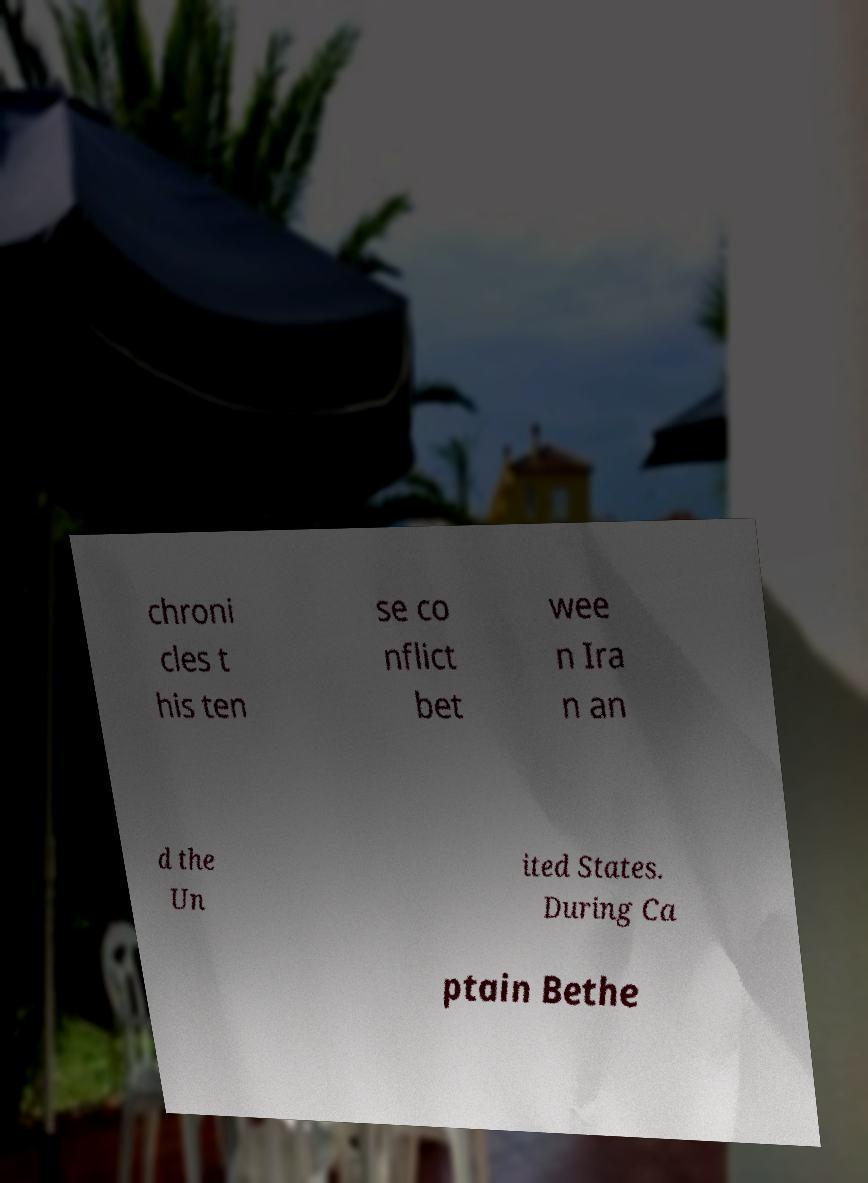There's text embedded in this image that I need extracted. Can you transcribe it verbatim? chroni cles t his ten se co nflict bet wee n Ira n an d the Un ited States. During Ca ptain Bethe 